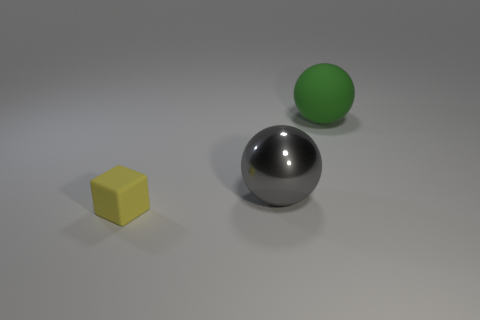The small yellow thing that is on the left side of the matte thing that is on the right side of the tiny yellow block is what shape?
Provide a short and direct response. Cube. There is a rubber thing in front of the gray metal object; is its color the same as the matte sphere?
Give a very brief answer. No. What color is the thing that is both in front of the large matte object and behind the tiny yellow rubber thing?
Your answer should be compact. Gray. Is there a green sphere made of the same material as the big green object?
Give a very brief answer. No. What size is the cube?
Ensure brevity in your answer.  Small. What is the size of the ball on the left side of the thing that is behind the large gray metallic ball?
Keep it short and to the point. Large. What is the material of the gray object that is the same shape as the green rubber thing?
Keep it short and to the point. Metal. How many tiny rubber things are there?
Offer a very short reply. 1. The big ball to the right of the sphere that is in front of the object that is behind the gray metallic ball is what color?
Offer a terse response. Green. Are there fewer large balls than large cyan objects?
Make the answer very short. No. 